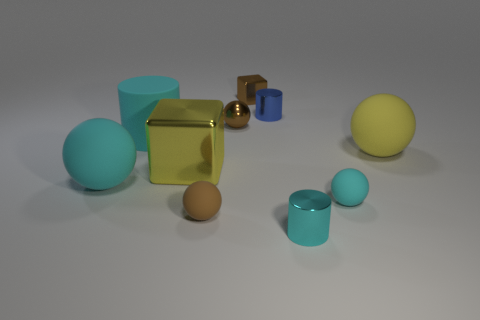Subtract all tiny cyan spheres. How many spheres are left? 4 Subtract all yellow balls. How many balls are left? 4 Subtract all blue spheres. Subtract all gray blocks. How many spheres are left? 5 Subtract all cubes. How many objects are left? 8 Subtract 0 red balls. How many objects are left? 10 Subtract all large matte cylinders. Subtract all small things. How many objects are left? 3 Add 3 large yellow shiny things. How many large yellow shiny things are left? 4 Add 10 big red matte cylinders. How many big red matte cylinders exist? 10 